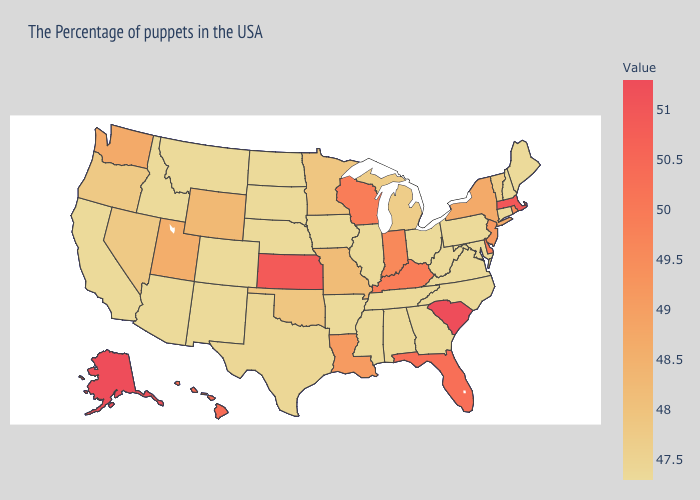Does Wyoming have a lower value than Michigan?
Concise answer only. No. Which states have the highest value in the USA?
Keep it brief. South Carolina, Alaska. Is the legend a continuous bar?
Quick response, please. Yes. Does California have the lowest value in the West?
Answer briefly. Yes. Which states hav the highest value in the MidWest?
Be succinct. Kansas. Does Texas have the highest value in the South?
Give a very brief answer. No. Is the legend a continuous bar?
Keep it brief. Yes. 